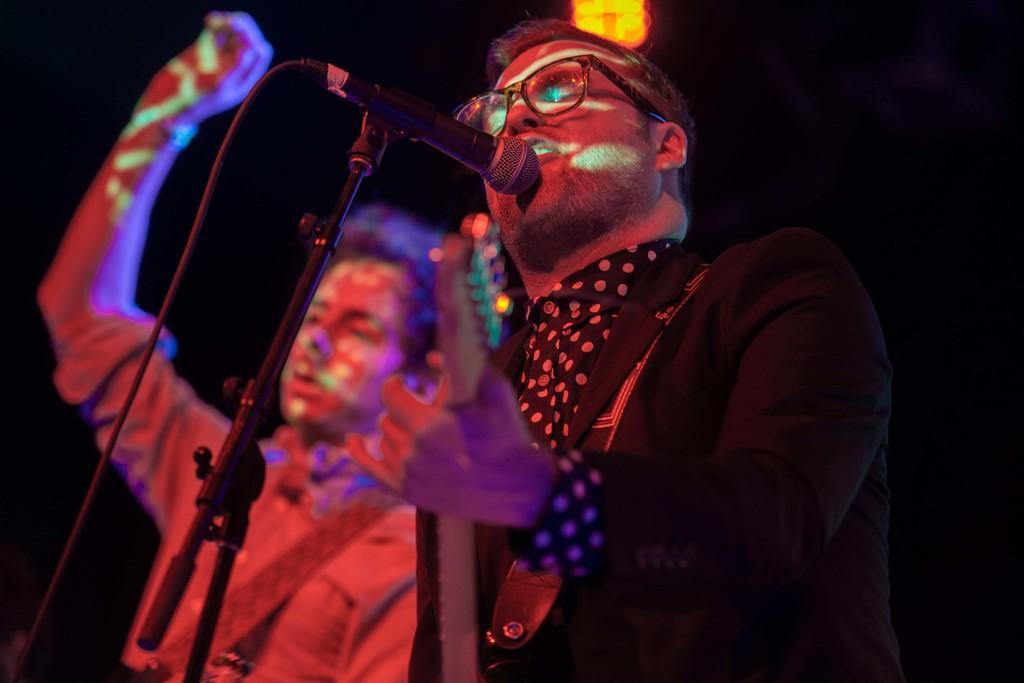How would you summarize this image in a sentence or two? This image looks like it is clicked in a concert. In the front, there is a man wearing black suit is singing and playing guitar. To the left, The man is wearing a guitar. 